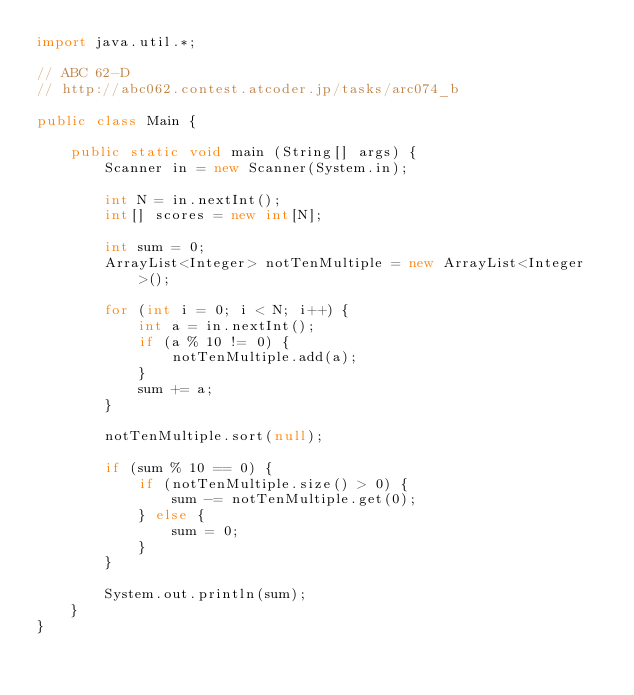Convert code to text. <code><loc_0><loc_0><loc_500><loc_500><_Java_>import java.util.*;

// ABC 62-D
// http://abc062.contest.atcoder.jp/tasks/arc074_b

public class Main {
	
	public static void main (String[] args) {
		Scanner in = new Scanner(System.in);
		
		int N = in.nextInt();
		int[] scores = new int[N];
		
		int sum = 0;
		ArrayList<Integer> notTenMultiple = new ArrayList<Integer>();
		
		for (int i = 0; i < N; i++) {
			int a = in.nextInt();
			if (a % 10 != 0) {
				notTenMultiple.add(a);
			}
			sum += a;
		}

		notTenMultiple.sort(null);
		
		if (sum % 10 == 0) {
			if (notTenMultiple.size() > 0) {
				sum -= notTenMultiple.get(0);
			} else {
				sum = 0;
			}
		}
		
		System.out.println(sum);
	}
}</code> 